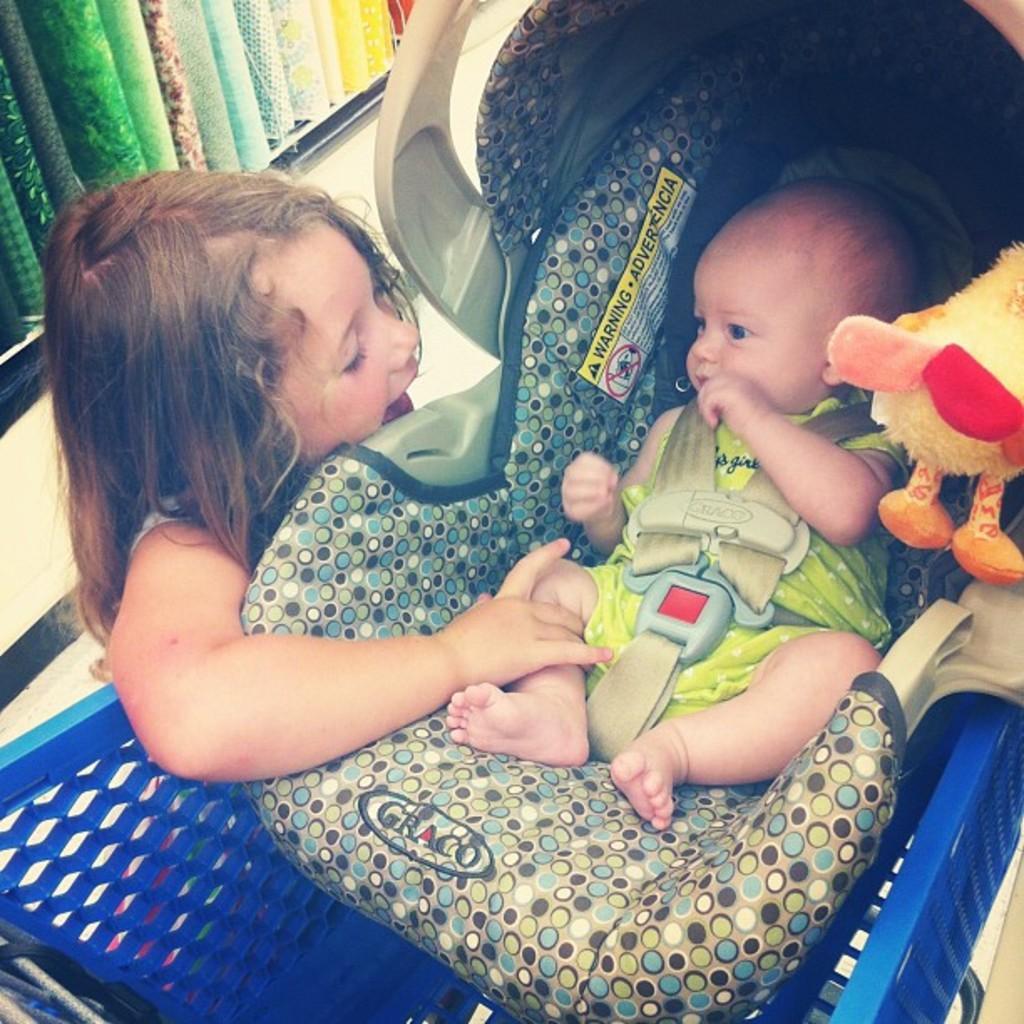In one or two sentences, can you explain what this image depicts? In this image we can see a baby sitting in the stroller and a kid is beside the stroller, there is a doll on the left side and there are few objects looks like clothes on the shelf. 